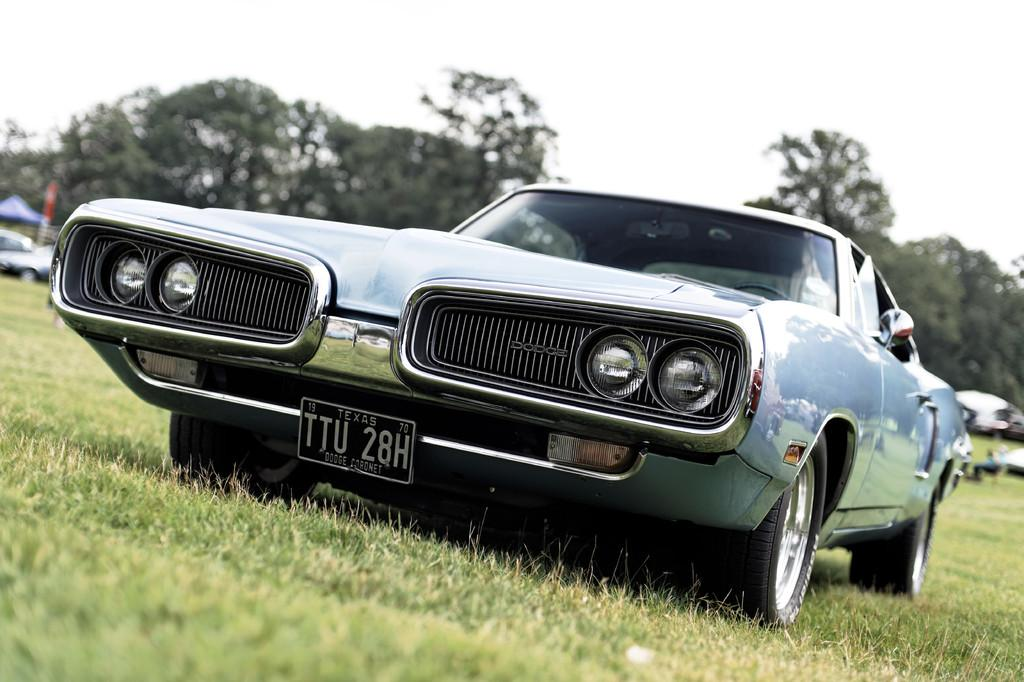What is the main subject in the center of the image? There is a car in the center of the image. What type of terrain is visible at the bottom side of the image? There is grassland at the bottom side of the image. What type of bird can be seen flying in the hall in the image? There is no hall or bird present in the image; it features a car and grassland. 